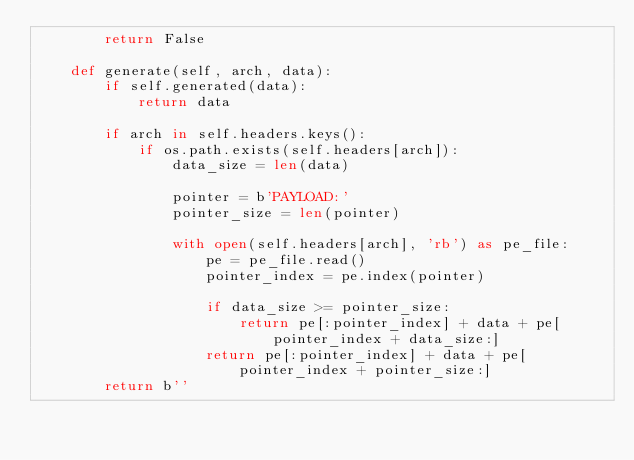Convert code to text. <code><loc_0><loc_0><loc_500><loc_500><_Python_>        return False

    def generate(self, arch, data):
        if self.generated(data):
            return data

        if arch in self.headers.keys():
            if os.path.exists(self.headers[arch]):
                data_size = len(data)

                pointer = b'PAYLOAD:'
                pointer_size = len(pointer)

                with open(self.headers[arch], 'rb') as pe_file:
                    pe = pe_file.read()
                    pointer_index = pe.index(pointer)

                    if data_size >= pointer_size:
                        return pe[:pointer_index] + data + pe[pointer_index + data_size:]
                    return pe[:pointer_index] + data + pe[pointer_index + pointer_size:]
        return b''
</code> 